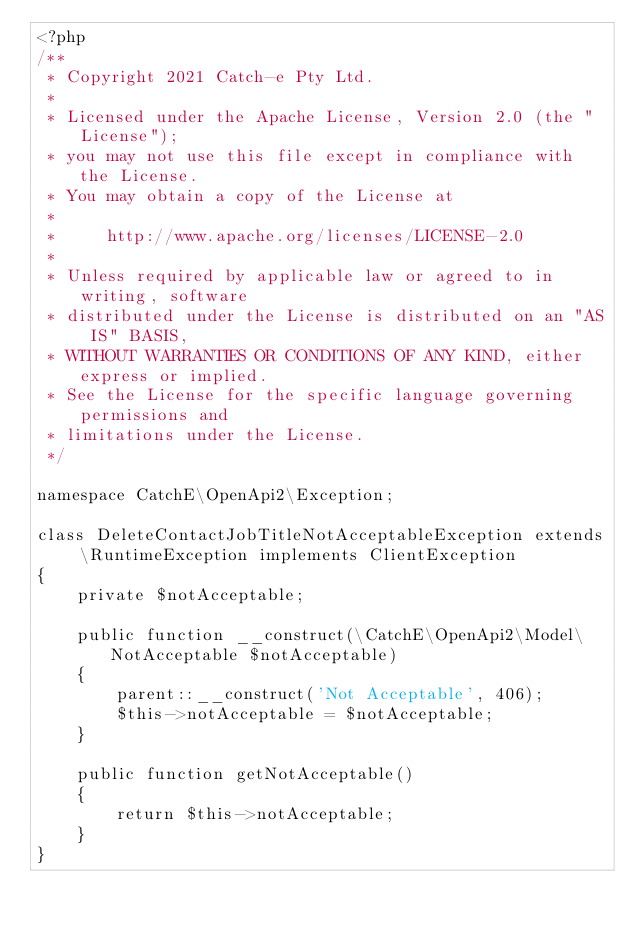Convert code to text. <code><loc_0><loc_0><loc_500><loc_500><_PHP_><?php
/**
 * Copyright 2021 Catch-e Pty Ltd.
 *
 * Licensed under the Apache License, Version 2.0 (the "License");
 * you may not use this file except in compliance with the License.
 * You may obtain a copy of the License at
 *
 *     http://www.apache.org/licenses/LICENSE-2.0
 *
 * Unless required by applicable law or agreed to in writing, software
 * distributed under the License is distributed on an "AS IS" BASIS,
 * WITHOUT WARRANTIES OR CONDITIONS OF ANY KIND, either express or implied.
 * See the License for the specific language governing permissions and
 * limitations under the License.
 */

namespace CatchE\OpenApi2\Exception;

class DeleteContactJobTitleNotAcceptableException extends \RuntimeException implements ClientException
{
	private $notAcceptable;

	public function __construct(\CatchE\OpenApi2\Model\NotAcceptable $notAcceptable)
	{
		parent::__construct('Not Acceptable', 406);
		$this->notAcceptable = $notAcceptable;
	}

	public function getNotAcceptable()
	{
		return $this->notAcceptable;
	}
}
</code> 